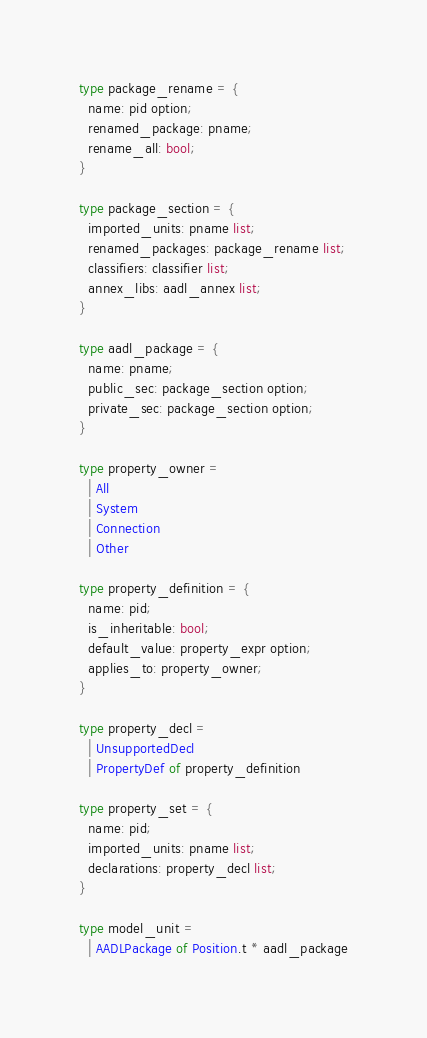Convert code to text. <code><loc_0><loc_0><loc_500><loc_500><_OCaml_>
type package_rename = {
  name: pid option;
  renamed_package: pname;
  rename_all: bool;
}

type package_section = {
  imported_units: pname list;
  renamed_packages: package_rename list;
  classifiers: classifier list;
  annex_libs: aadl_annex list;
}

type aadl_package = {
  name: pname;
  public_sec: package_section option;
  private_sec: package_section option;
}

type property_owner =
  | All
  | System
  | Connection
  | Other

type property_definition = {
  name: pid;
  is_inheritable: bool;
  default_value: property_expr option;
  applies_to: property_owner;
}

type property_decl =
  | UnsupportedDecl
  | PropertyDef of property_definition

type property_set = {
  name: pid;
  imported_units: pname list;
  declarations: property_decl list;
}

type model_unit =
  | AADLPackage of Position.t * aadl_package</code> 